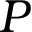<formula> <loc_0><loc_0><loc_500><loc_500>P</formula> 